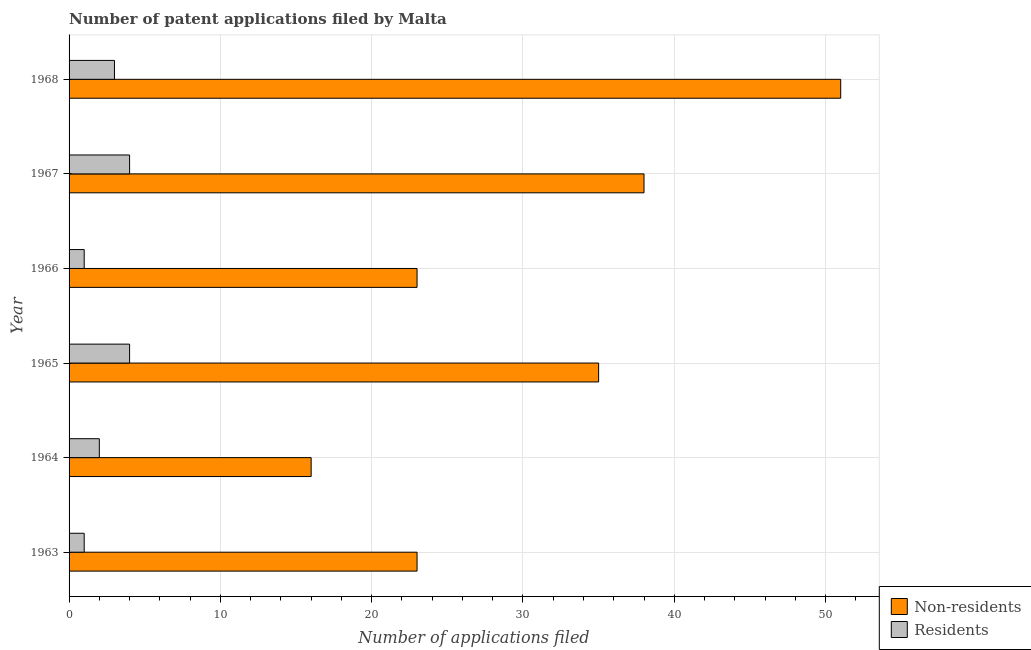How many different coloured bars are there?
Your answer should be compact. 2. How many groups of bars are there?
Your response must be concise. 6. Are the number of bars per tick equal to the number of legend labels?
Your response must be concise. Yes. Are the number of bars on each tick of the Y-axis equal?
Offer a very short reply. Yes. How many bars are there on the 5th tick from the bottom?
Your answer should be compact. 2. What is the label of the 4th group of bars from the top?
Provide a succinct answer. 1965. In how many cases, is the number of bars for a given year not equal to the number of legend labels?
Provide a succinct answer. 0. What is the number of patent applications by non residents in 1963?
Ensure brevity in your answer.  23. Across all years, what is the maximum number of patent applications by non residents?
Your response must be concise. 51. Across all years, what is the minimum number of patent applications by residents?
Your answer should be compact. 1. In which year was the number of patent applications by residents maximum?
Offer a very short reply. 1965. In which year was the number of patent applications by non residents minimum?
Keep it short and to the point. 1964. What is the total number of patent applications by residents in the graph?
Keep it short and to the point. 15. What is the difference between the number of patent applications by non residents in 1966 and that in 1967?
Your answer should be very brief. -15. What is the difference between the number of patent applications by residents in 1967 and the number of patent applications by non residents in 1965?
Provide a succinct answer. -31. What is the average number of patent applications by non residents per year?
Your answer should be very brief. 31. In the year 1968, what is the difference between the number of patent applications by non residents and number of patent applications by residents?
Provide a short and direct response. 48. In how many years, is the number of patent applications by residents greater than 48 ?
Your answer should be very brief. 0. What is the ratio of the number of patent applications by non residents in 1963 to that in 1965?
Make the answer very short. 0.66. What is the difference between the highest and the lowest number of patent applications by residents?
Your answer should be compact. 3. In how many years, is the number of patent applications by non residents greater than the average number of patent applications by non residents taken over all years?
Keep it short and to the point. 3. Is the sum of the number of patent applications by non residents in 1963 and 1964 greater than the maximum number of patent applications by residents across all years?
Provide a succinct answer. Yes. What does the 1st bar from the top in 1968 represents?
Provide a short and direct response. Residents. What does the 2nd bar from the bottom in 1967 represents?
Offer a very short reply. Residents. Are all the bars in the graph horizontal?
Offer a terse response. Yes. How many years are there in the graph?
Offer a terse response. 6. What is the difference between two consecutive major ticks on the X-axis?
Give a very brief answer. 10. Are the values on the major ticks of X-axis written in scientific E-notation?
Provide a short and direct response. No. Does the graph contain any zero values?
Your response must be concise. No. Does the graph contain grids?
Your response must be concise. Yes. What is the title of the graph?
Offer a very short reply. Number of patent applications filed by Malta. Does "Agricultural land" appear as one of the legend labels in the graph?
Offer a very short reply. No. What is the label or title of the X-axis?
Ensure brevity in your answer.  Number of applications filed. What is the label or title of the Y-axis?
Offer a terse response. Year. What is the Number of applications filed of Residents in 1963?
Make the answer very short. 1. What is the Number of applications filed in Residents in 1964?
Your answer should be very brief. 2. What is the Number of applications filed of Residents in 1965?
Give a very brief answer. 4. What is the Number of applications filed of Non-residents in 1966?
Provide a short and direct response. 23. What is the Number of applications filed of Residents in 1966?
Give a very brief answer. 1. What is the Number of applications filed in Non-residents in 1967?
Your answer should be compact. 38. What is the Number of applications filed in Residents in 1967?
Your answer should be very brief. 4. Across all years, what is the minimum Number of applications filed in Residents?
Ensure brevity in your answer.  1. What is the total Number of applications filed of Non-residents in the graph?
Give a very brief answer. 186. What is the difference between the Number of applications filed of Residents in 1963 and that in 1964?
Keep it short and to the point. -1. What is the difference between the Number of applications filed of Non-residents in 1963 and that in 1965?
Give a very brief answer. -12. What is the difference between the Number of applications filed of Residents in 1963 and that in 1966?
Provide a succinct answer. 0. What is the difference between the Number of applications filed of Non-residents in 1963 and that in 1967?
Ensure brevity in your answer.  -15. What is the difference between the Number of applications filed of Non-residents in 1963 and that in 1968?
Offer a terse response. -28. What is the difference between the Number of applications filed of Residents in 1964 and that in 1965?
Ensure brevity in your answer.  -2. What is the difference between the Number of applications filed of Residents in 1964 and that in 1966?
Your answer should be very brief. 1. What is the difference between the Number of applications filed in Residents in 1964 and that in 1967?
Give a very brief answer. -2. What is the difference between the Number of applications filed of Non-residents in 1964 and that in 1968?
Offer a very short reply. -35. What is the difference between the Number of applications filed in Residents in 1964 and that in 1968?
Offer a terse response. -1. What is the difference between the Number of applications filed in Residents in 1965 and that in 1966?
Ensure brevity in your answer.  3. What is the difference between the Number of applications filed of Residents in 1965 and that in 1967?
Provide a short and direct response. 0. What is the difference between the Number of applications filed of Non-residents in 1965 and that in 1968?
Your answer should be compact. -16. What is the difference between the Number of applications filed of Residents in 1965 and that in 1968?
Ensure brevity in your answer.  1. What is the difference between the Number of applications filed of Non-residents in 1967 and that in 1968?
Provide a short and direct response. -13. What is the difference between the Number of applications filed in Residents in 1967 and that in 1968?
Offer a very short reply. 1. What is the difference between the Number of applications filed of Non-residents in 1963 and the Number of applications filed of Residents in 1965?
Your response must be concise. 19. What is the difference between the Number of applications filed of Non-residents in 1963 and the Number of applications filed of Residents in 1967?
Provide a short and direct response. 19. What is the difference between the Number of applications filed in Non-residents in 1964 and the Number of applications filed in Residents in 1965?
Your answer should be very brief. 12. What is the difference between the Number of applications filed in Non-residents in 1964 and the Number of applications filed in Residents in 1967?
Ensure brevity in your answer.  12. What is the difference between the Number of applications filed in Non-residents in 1965 and the Number of applications filed in Residents in 1966?
Your answer should be compact. 34. What is the difference between the Number of applications filed in Non-residents in 1965 and the Number of applications filed in Residents in 1967?
Keep it short and to the point. 31. What is the difference between the Number of applications filed in Non-residents in 1965 and the Number of applications filed in Residents in 1968?
Offer a terse response. 32. What is the average Number of applications filed of Residents per year?
Provide a succinct answer. 2.5. In the year 1964, what is the difference between the Number of applications filed of Non-residents and Number of applications filed of Residents?
Give a very brief answer. 14. In the year 1965, what is the difference between the Number of applications filed of Non-residents and Number of applications filed of Residents?
Keep it short and to the point. 31. In the year 1968, what is the difference between the Number of applications filed of Non-residents and Number of applications filed of Residents?
Your response must be concise. 48. What is the ratio of the Number of applications filed in Non-residents in 1963 to that in 1964?
Ensure brevity in your answer.  1.44. What is the ratio of the Number of applications filed in Non-residents in 1963 to that in 1965?
Make the answer very short. 0.66. What is the ratio of the Number of applications filed in Residents in 1963 to that in 1965?
Give a very brief answer. 0.25. What is the ratio of the Number of applications filed in Residents in 1963 to that in 1966?
Your answer should be very brief. 1. What is the ratio of the Number of applications filed of Non-residents in 1963 to that in 1967?
Provide a short and direct response. 0.61. What is the ratio of the Number of applications filed of Non-residents in 1963 to that in 1968?
Your answer should be very brief. 0.45. What is the ratio of the Number of applications filed of Non-residents in 1964 to that in 1965?
Provide a succinct answer. 0.46. What is the ratio of the Number of applications filed in Residents in 1964 to that in 1965?
Your response must be concise. 0.5. What is the ratio of the Number of applications filed in Non-residents in 1964 to that in 1966?
Give a very brief answer. 0.7. What is the ratio of the Number of applications filed of Non-residents in 1964 to that in 1967?
Keep it short and to the point. 0.42. What is the ratio of the Number of applications filed of Non-residents in 1964 to that in 1968?
Keep it short and to the point. 0.31. What is the ratio of the Number of applications filed in Residents in 1964 to that in 1968?
Provide a short and direct response. 0.67. What is the ratio of the Number of applications filed of Non-residents in 1965 to that in 1966?
Provide a succinct answer. 1.52. What is the ratio of the Number of applications filed of Residents in 1965 to that in 1966?
Offer a terse response. 4. What is the ratio of the Number of applications filed of Non-residents in 1965 to that in 1967?
Keep it short and to the point. 0.92. What is the ratio of the Number of applications filed in Residents in 1965 to that in 1967?
Give a very brief answer. 1. What is the ratio of the Number of applications filed in Non-residents in 1965 to that in 1968?
Provide a short and direct response. 0.69. What is the ratio of the Number of applications filed of Non-residents in 1966 to that in 1967?
Provide a succinct answer. 0.61. What is the ratio of the Number of applications filed in Residents in 1966 to that in 1967?
Offer a terse response. 0.25. What is the ratio of the Number of applications filed in Non-residents in 1966 to that in 1968?
Provide a succinct answer. 0.45. What is the ratio of the Number of applications filed of Non-residents in 1967 to that in 1968?
Ensure brevity in your answer.  0.75. What is the difference between the highest and the second highest Number of applications filed in Non-residents?
Offer a very short reply. 13. What is the difference between the highest and the second highest Number of applications filed in Residents?
Give a very brief answer. 0. What is the difference between the highest and the lowest Number of applications filed in Non-residents?
Ensure brevity in your answer.  35. 